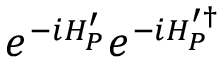<formula> <loc_0><loc_0><loc_500><loc_500>e ^ { - i H _ { P } ^ { \prime } } e ^ { - i H _ { P } ^ { \prime \dagger } }</formula> 